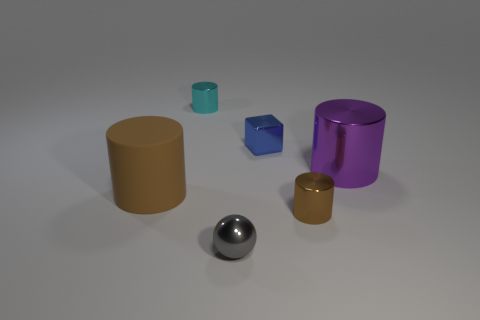Add 3 tiny brown things. How many objects exist? 9 Subtract all blocks. How many objects are left? 5 Add 6 small cyan metal blocks. How many small cyan metal blocks exist? 6 Subtract 0 brown spheres. How many objects are left? 6 Subtract all tiny cyan rubber objects. Subtract all tiny cyan things. How many objects are left? 5 Add 5 brown metal cylinders. How many brown metal cylinders are left? 6 